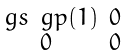Convert formula to latex. <formula><loc_0><loc_0><loc_500><loc_500>\begin{smallmatrix} \ g s \ g p ( 1 ) & 0 \\ 0 & 0 \end{smallmatrix}</formula> 